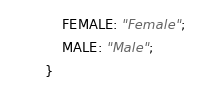<code> <loc_0><loc_0><loc_500><loc_500><_ObjectiveC_>    FEMALE: "Female";
    MALE: "Male";
}</code> 